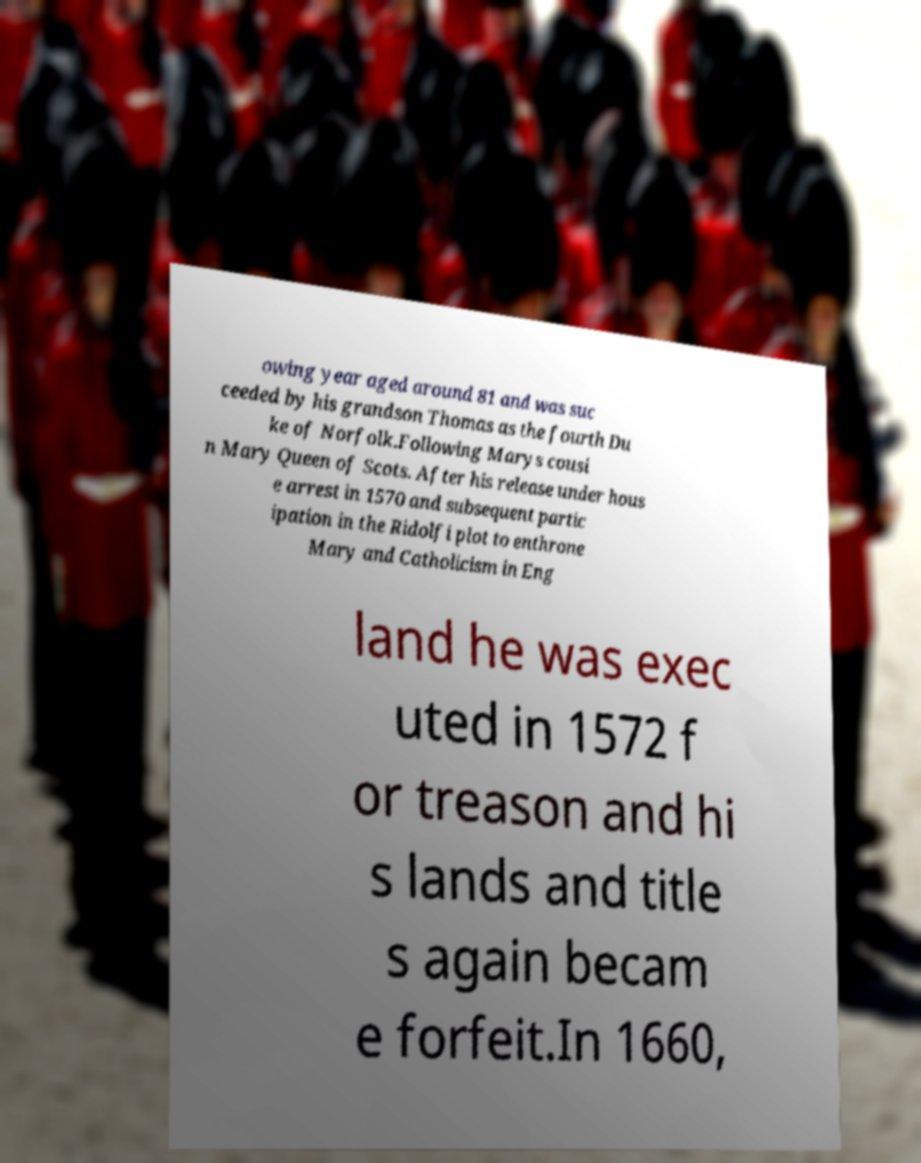For documentation purposes, I need the text within this image transcribed. Could you provide that? owing year aged around 81 and was suc ceeded by his grandson Thomas as the fourth Du ke of Norfolk.Following Marys cousi n Mary Queen of Scots. After his release under hous e arrest in 1570 and subsequent partic ipation in the Ridolfi plot to enthrone Mary and Catholicism in Eng land he was exec uted in 1572 f or treason and hi s lands and title s again becam e forfeit.In 1660, 